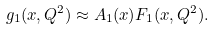<formula> <loc_0><loc_0><loc_500><loc_500>g _ { 1 } ( x , Q ^ { 2 } ) \approx A _ { 1 } ( x ) F _ { 1 } ( x , Q ^ { 2 } ) .</formula> 